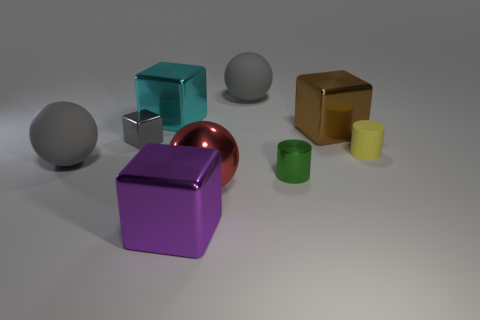There is a small object that is the same shape as the big brown metal object; what is its color?
Your answer should be compact. Gray. Do the large rubber sphere that is to the right of the purple metallic block and the tiny metallic block have the same color?
Your response must be concise. Yes. What number of shiny things are there?
Your response must be concise. 6. Is the big gray object that is in front of the cyan metal cube made of the same material as the tiny yellow cylinder?
Keep it short and to the point. Yes. How many cyan metallic things are behind the tiny shiny thing right of the metal thing to the left of the cyan thing?
Your response must be concise. 1. What is the size of the yellow rubber cylinder?
Ensure brevity in your answer.  Small. There is a shiny cylinder that is to the left of the rubber cylinder; what is its size?
Ensure brevity in your answer.  Small. Do the big matte ball to the right of the large purple block and the small metallic thing behind the small green object have the same color?
Offer a very short reply. Yes. What number of other objects are the same shape as the cyan metallic object?
Offer a very short reply. 3. Is the number of yellow objects that are in front of the tiny green object the same as the number of big cyan metal things that are to the right of the small yellow matte cylinder?
Ensure brevity in your answer.  Yes. 